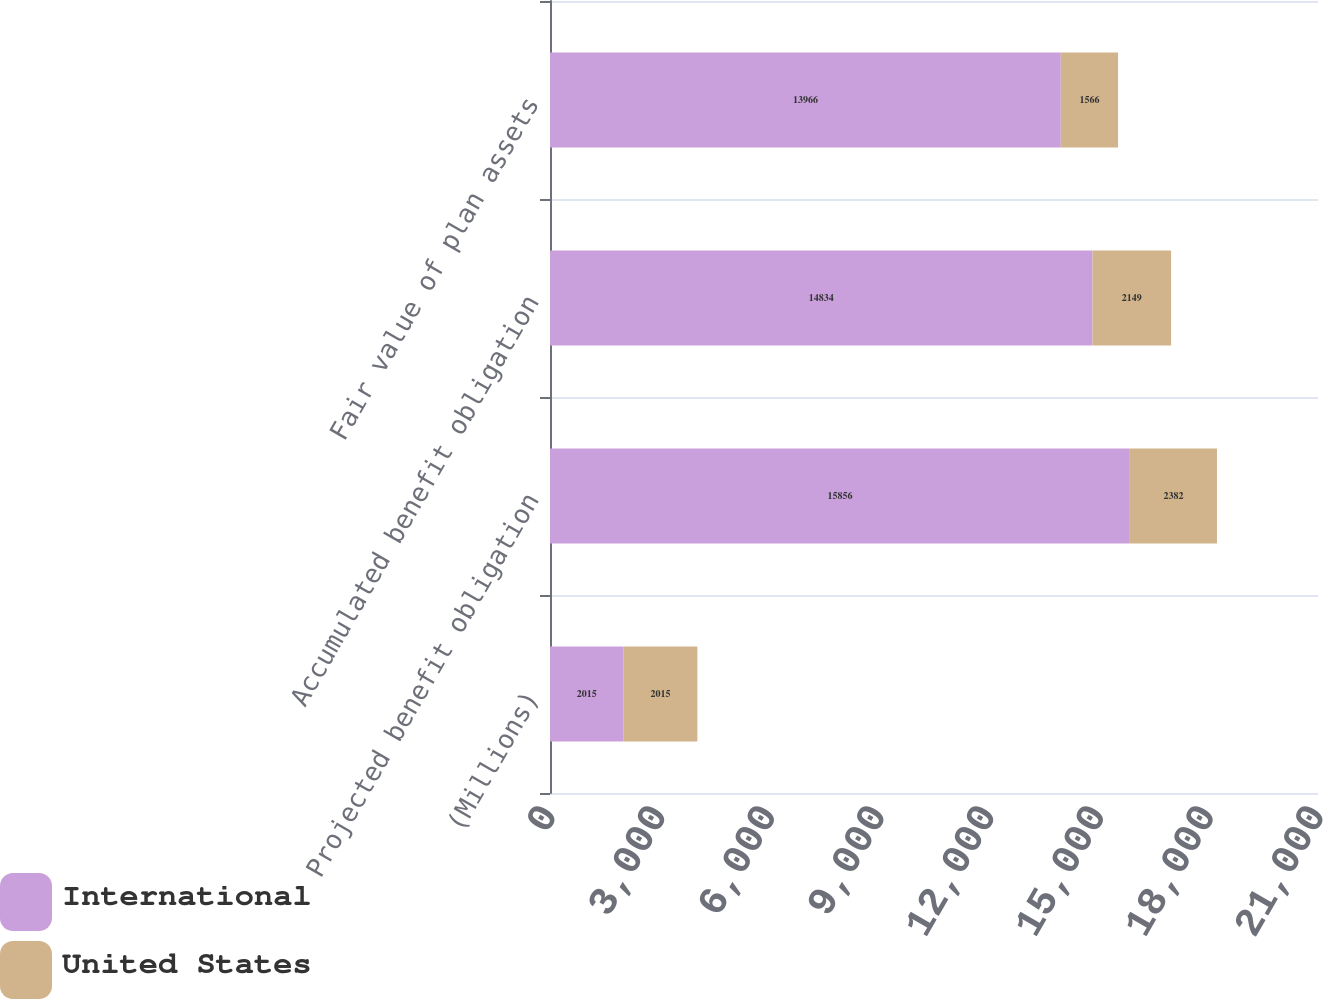Convert chart. <chart><loc_0><loc_0><loc_500><loc_500><stacked_bar_chart><ecel><fcel>(Millions)<fcel>Projected benefit obligation<fcel>Accumulated benefit obligation<fcel>Fair value of plan assets<nl><fcel>International<fcel>2015<fcel>15856<fcel>14834<fcel>13966<nl><fcel>United States<fcel>2015<fcel>2382<fcel>2149<fcel>1566<nl></chart> 